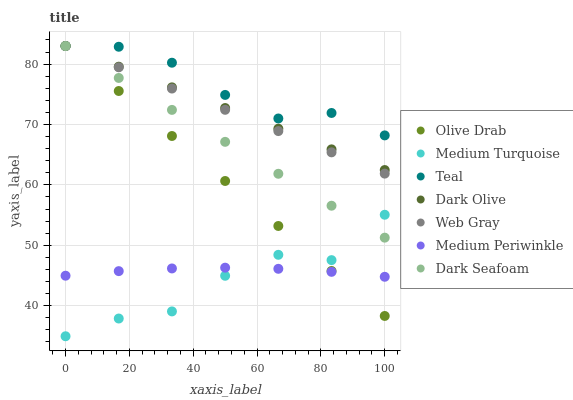Does Medium Turquoise have the minimum area under the curve?
Answer yes or no. Yes. Does Teal have the maximum area under the curve?
Answer yes or no. Yes. Does Dark Olive have the minimum area under the curve?
Answer yes or no. No. Does Dark Olive have the maximum area under the curve?
Answer yes or no. No. Is Dark Olive the smoothest?
Answer yes or no. Yes. Is Medium Turquoise the roughest?
Answer yes or no. Yes. Is Medium Turquoise the smoothest?
Answer yes or no. No. Is Dark Olive the roughest?
Answer yes or no. No. Does Medium Turquoise have the lowest value?
Answer yes or no. Yes. Does Dark Olive have the lowest value?
Answer yes or no. No. Does Olive Drab have the highest value?
Answer yes or no. Yes. Does Medium Turquoise have the highest value?
Answer yes or no. No. Is Medium Periwinkle less than Teal?
Answer yes or no. Yes. Is Dark Olive greater than Medium Turquoise?
Answer yes or no. Yes. Does Dark Olive intersect Web Gray?
Answer yes or no. Yes. Is Dark Olive less than Web Gray?
Answer yes or no. No. Is Dark Olive greater than Web Gray?
Answer yes or no. No. Does Medium Periwinkle intersect Teal?
Answer yes or no. No. 